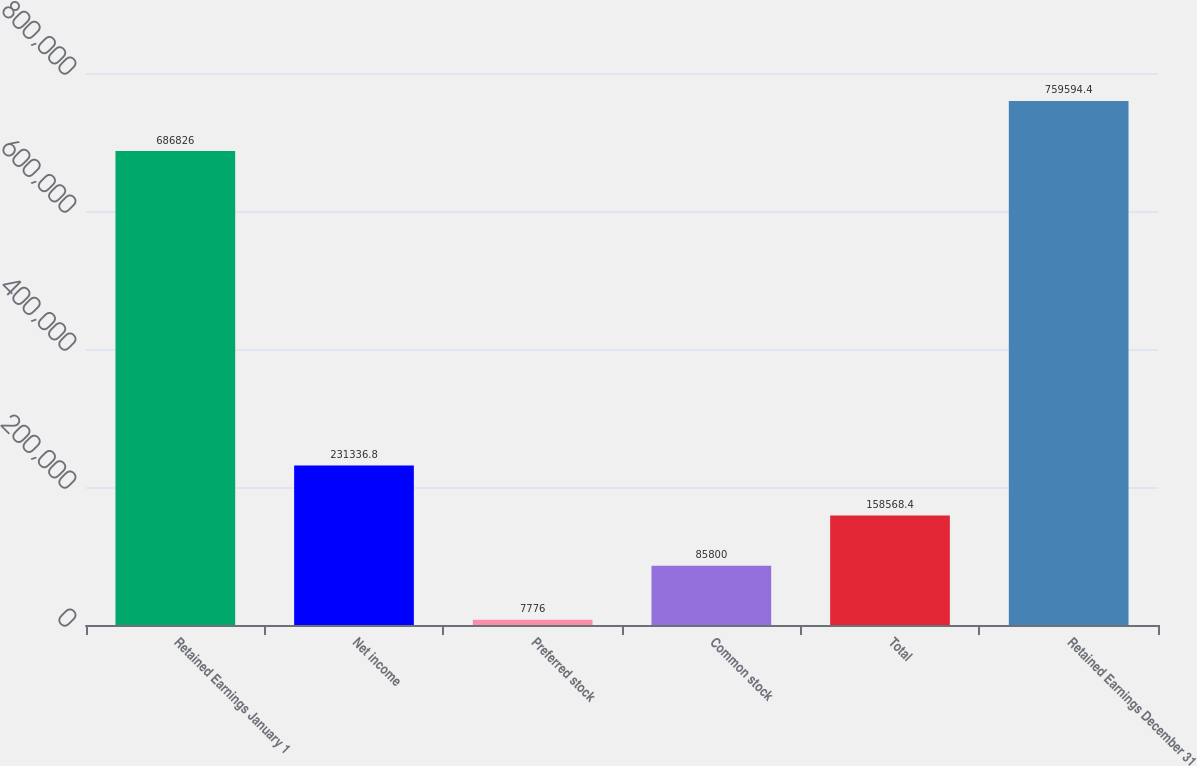Convert chart to OTSL. <chart><loc_0><loc_0><loc_500><loc_500><bar_chart><fcel>Retained Earnings January 1<fcel>Net income<fcel>Preferred stock<fcel>Common stock<fcel>Total<fcel>Retained Earnings December 31<nl><fcel>686826<fcel>231337<fcel>7776<fcel>85800<fcel>158568<fcel>759594<nl></chart> 